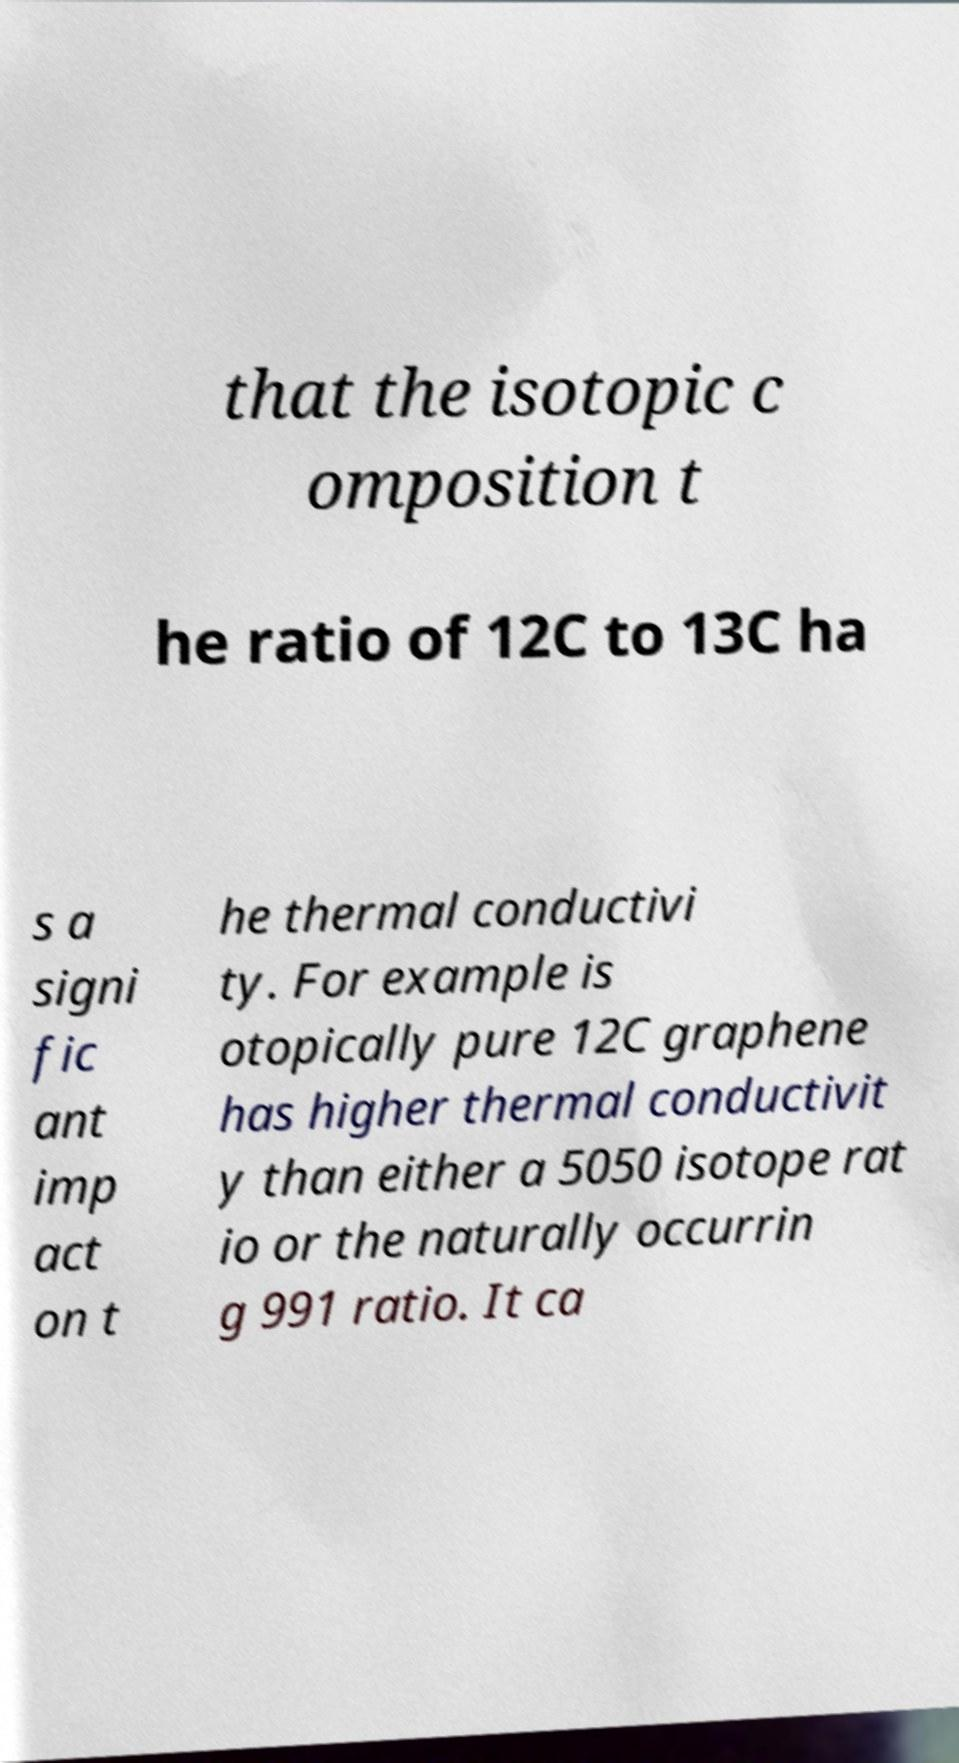What messages or text are displayed in this image? I need them in a readable, typed format. that the isotopic c omposition t he ratio of 12C to 13C ha s a signi fic ant imp act on t he thermal conductivi ty. For example is otopically pure 12C graphene has higher thermal conductivit y than either a 5050 isotope rat io or the naturally occurrin g 991 ratio. It ca 